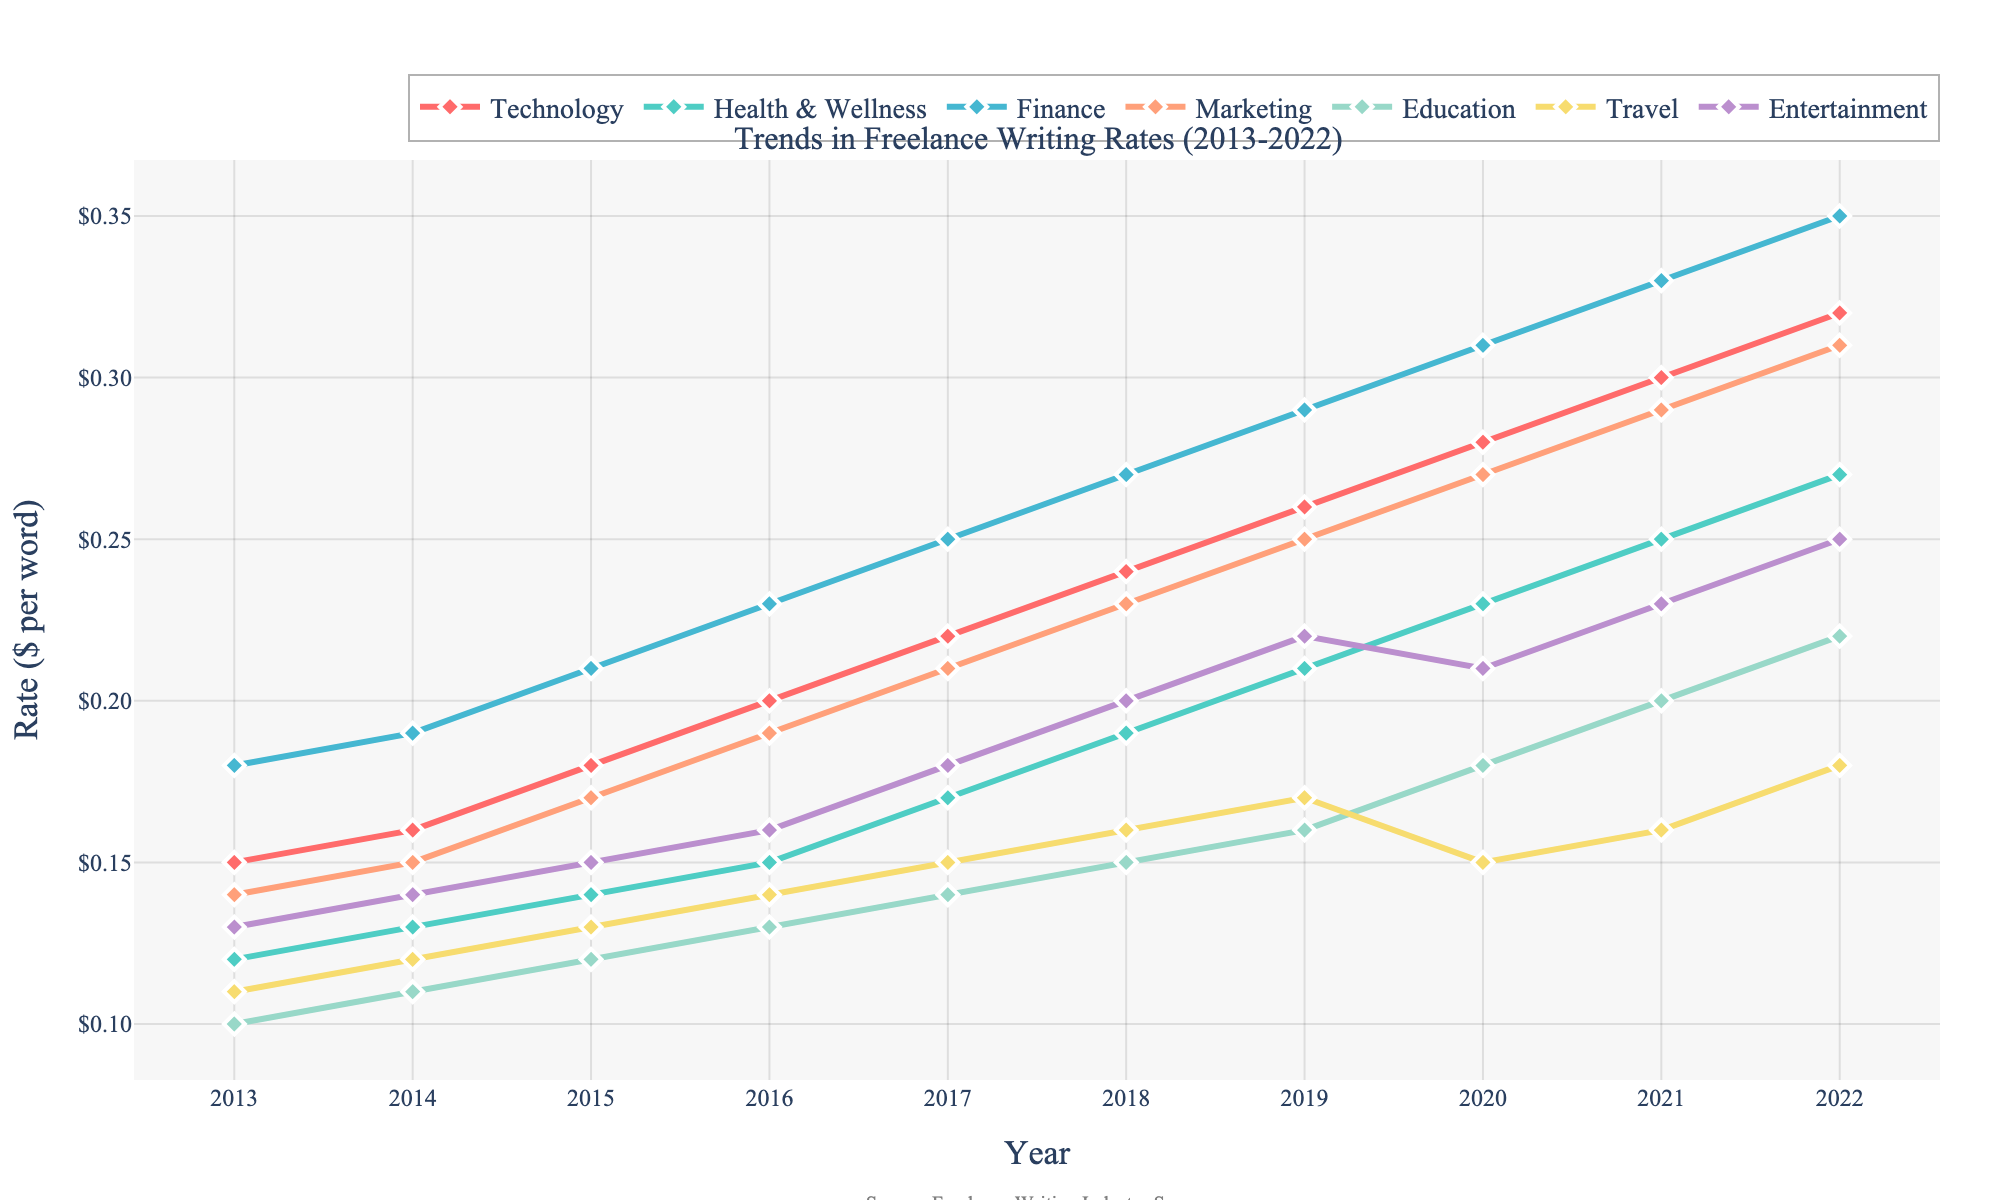What industry shows the highest rate per word in 2022? Look at the line chart and identify the line that reaches the highest point in 2022. Compare the end points of each line representing the different industries. The finance industry's line is the highest in 2022.
Answer: Finance Which industry had the slowest rate increase from 2013 to 2022? Examine the slopes of the lines for each industry. The less steep the slope, the slower the rate increase. The travel industry has the least steep slope compared to others, indicating the slowest rate increase.
Answer: Travel By how much did the rate per word for Technology increase from 2013 to 2022? Find the 2013 rate and the 2022 rate for Technology in the plot, then subtract the 2013 rate from the 2022 rate. The rate increased from $0.15 to $0.32. The difference is $0.32 - $0.15 = $0.17.
Answer: $0.17 Between which two consecutive years did Finance see the greatest rate increase? Look for the largest vertical distance between consecutive points on the Finance line. The most significant gap is between 2021 and 2022.
Answer: 2021-2022 Which industry surpassed the $0.20 per word rate first, and in what year? Identify the point where each industry's line first crosses the $0.20 mark, then determine the earliest of these points. Health & Wellness was the first to surpass $0.20 in 2018.
Answer: Health & Wellness, 2018 Which industry had the most consistent rate increase from 2013 to 2022? Identify the line that has the most linear and uniform increase over the years. The Marketing industry shows a consistent increase without abrupt changes.
Answer: Marketing How did the Education industry's rate change between 2017 and 2022? Identify the rate per word in 2017 and 2022, and then calculate the difference. The rate increased from $0.14 to $0.22. The change is $0.22 - $0.14 = $0.08.
Answer: $0.08 Compare the rate trends for Technology and Entertainment. Which had a more rapid increase post-2018? Examine the slopes of the lines for Technology and Entertainment after 2018. Technology has a steeper rise, indicating a more rapid increase.
Answer: Technology Calculate the average rate per word for Finance over the decade. Add up the Finance rates from 2013 to 2022 and divide by the number of years (10). The total is $0.18 + $0.19 + $0.21 + $0.23 + $0.25 + $0.27 + $0.29 + $0.31 + $0.33 + $0.35 = $2.61, and the average is $2.61 / 10 = $0.261.
Answer: $0.261 Which industry saw a decrease in rates at any point, and in what year? Look for any dipping points in lines where the rate decreases from one year to the next. Both Travel and Entertainment saw decreases; Travel from 2019 to 2020, and Entertainment from 2019 to 2020.
Answer: Travel, 2019-2020 and Entertainment, 2019-2020 